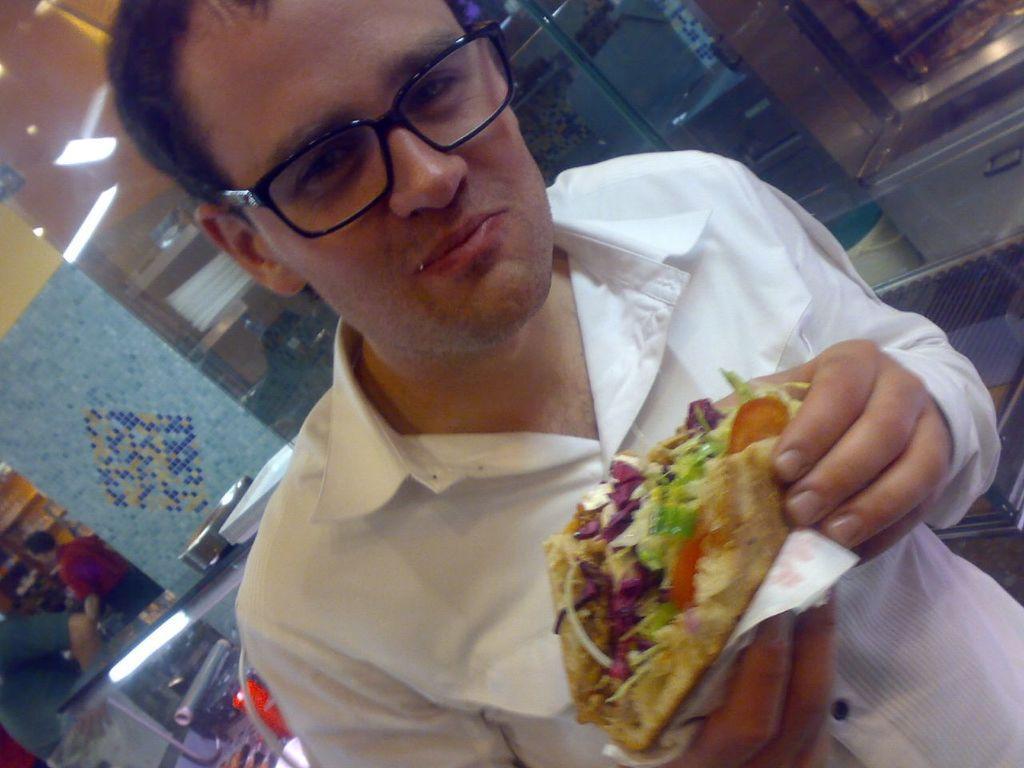Please provide a concise description of this image. In this picture there is a man standing in the front and holding food in his hand. In the background there are plates on the table and there are persons standing, there is a pillar. 